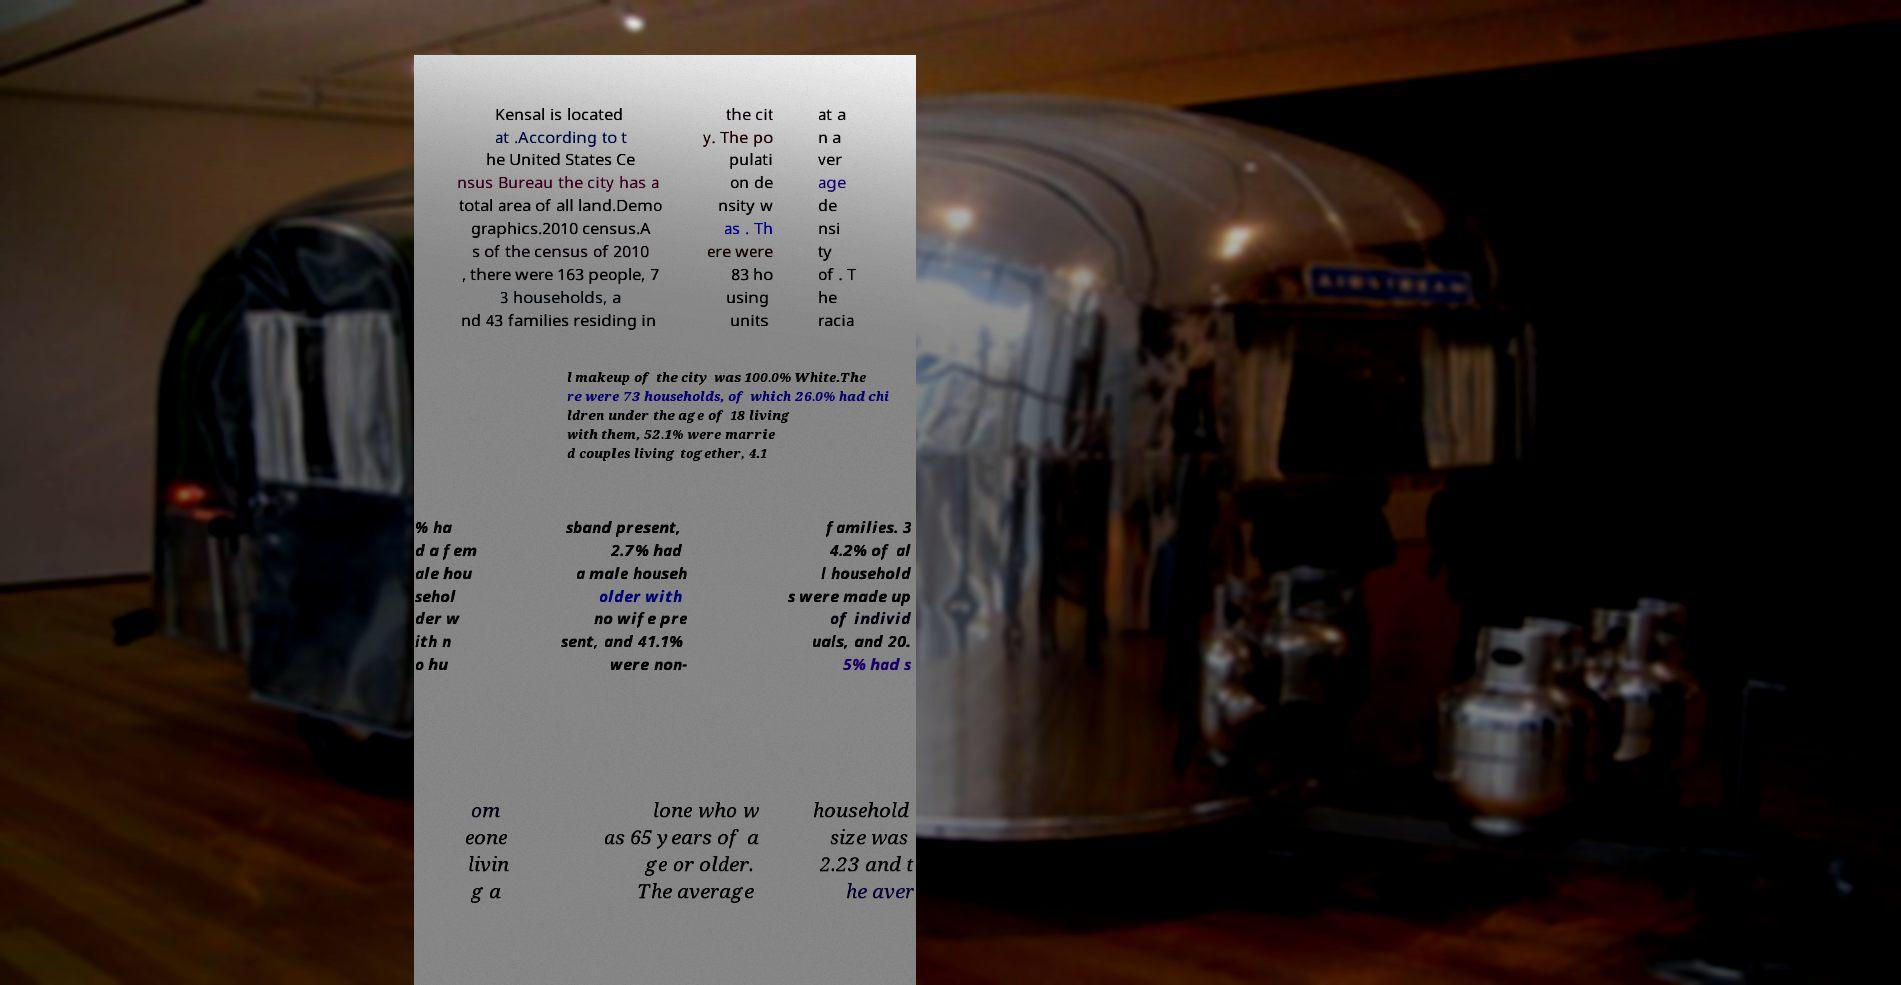Could you extract and type out the text from this image? Kensal is located at .According to t he United States Ce nsus Bureau the city has a total area of all land.Demo graphics.2010 census.A s of the census of 2010 , there were 163 people, 7 3 households, a nd 43 families residing in the cit y. The po pulati on de nsity w as . Th ere were 83 ho using units at a n a ver age de nsi ty of . T he racia l makeup of the city was 100.0% White.The re were 73 households, of which 26.0% had chi ldren under the age of 18 living with them, 52.1% were marrie d couples living together, 4.1 % ha d a fem ale hou sehol der w ith n o hu sband present, 2.7% had a male househ older with no wife pre sent, and 41.1% were non- families. 3 4.2% of al l household s were made up of individ uals, and 20. 5% had s om eone livin g a lone who w as 65 years of a ge or older. The average household size was 2.23 and t he aver 